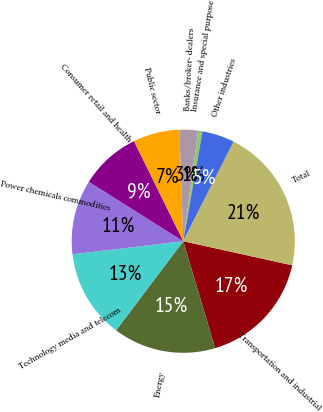Convert chart. <chart><loc_0><loc_0><loc_500><loc_500><pie_chart><fcel>Transportation and industrial<fcel>Energy<fcel>Technology media and telecom<fcel>Power chemicals commodities<fcel>Consumer retail and health<fcel>Public sector<fcel>Banks/broker- dealers<fcel>Insurance and special purpose<fcel>Other industries<fcel>Total<nl><fcel>16.93%<fcel>14.89%<fcel>12.85%<fcel>10.81%<fcel>8.78%<fcel>6.74%<fcel>2.67%<fcel>0.63%<fcel>4.7%<fcel>21.0%<nl></chart> 